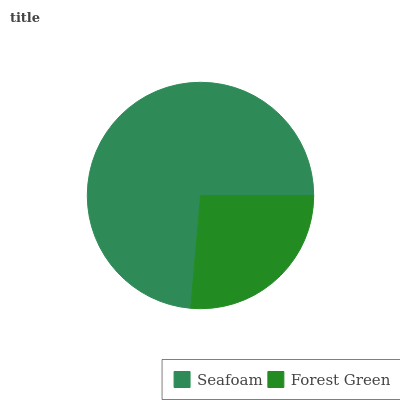Is Forest Green the minimum?
Answer yes or no. Yes. Is Seafoam the maximum?
Answer yes or no. Yes. Is Forest Green the maximum?
Answer yes or no. No. Is Seafoam greater than Forest Green?
Answer yes or no. Yes. Is Forest Green less than Seafoam?
Answer yes or no. Yes. Is Forest Green greater than Seafoam?
Answer yes or no. No. Is Seafoam less than Forest Green?
Answer yes or no. No. Is Seafoam the high median?
Answer yes or no. Yes. Is Forest Green the low median?
Answer yes or no. Yes. Is Forest Green the high median?
Answer yes or no. No. Is Seafoam the low median?
Answer yes or no. No. 